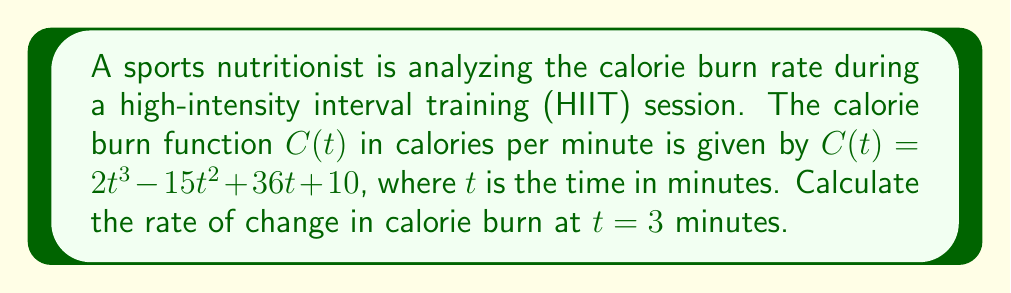Give your solution to this math problem. To find the rate of change in calorie burn at a specific time, we need to calculate the derivative of the calorie burn function $C(t)$ and evaluate it at $t = 3$ minutes.

Step 1: Find the derivative of $C(t)$.
$$\frac{d}{dt}C(t) = \frac{d}{dt}(2t^3 - 15t^2 + 36t + 10)$$
$$C'(t) = 6t^2 - 30t + 36$$

Step 2: Evaluate the derivative at $t = 3$ minutes.
$$C'(3) = 6(3)^2 - 30(3) + 36$$
$$C'(3) = 6(9) - 90 + 36$$
$$C'(3) = 54 - 90 + 36$$
$$C'(3) = 0$$

The rate of change in calorie burn at $t = 3$ minutes is 0 calories per minute per minute.
Answer: 0 cal/min² 